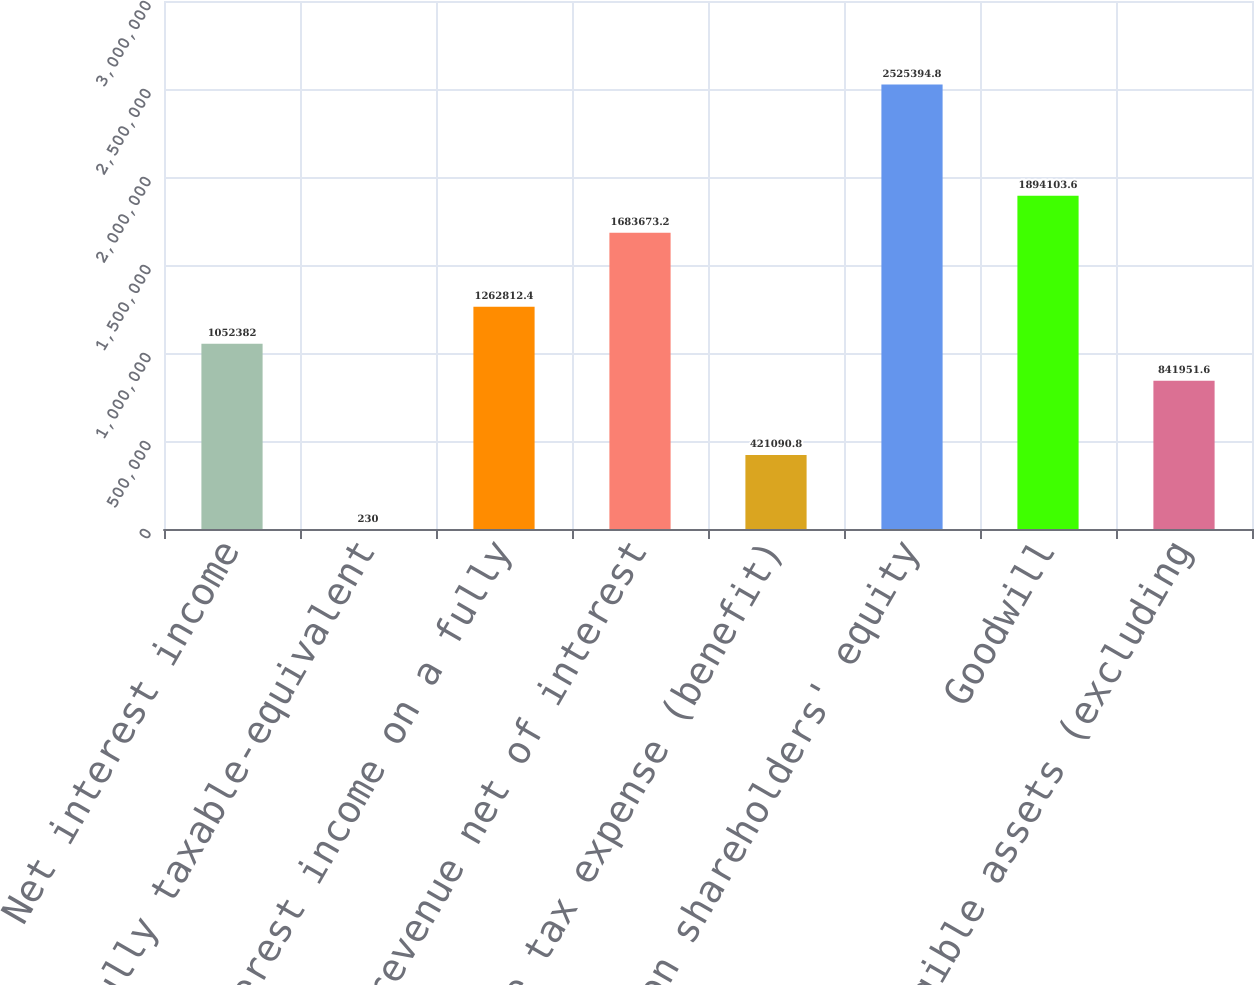<chart> <loc_0><loc_0><loc_500><loc_500><bar_chart><fcel>Net interest income<fcel>Fully taxable-equivalent<fcel>Net interest income on a fully<fcel>Total revenue net of interest<fcel>Income tax expense (benefit)<fcel>Common shareholders' equity<fcel>Goodwill<fcel>Intangible assets (excluding<nl><fcel>1.05238e+06<fcel>230<fcel>1.26281e+06<fcel>1.68367e+06<fcel>421091<fcel>2.52539e+06<fcel>1.8941e+06<fcel>841952<nl></chart> 